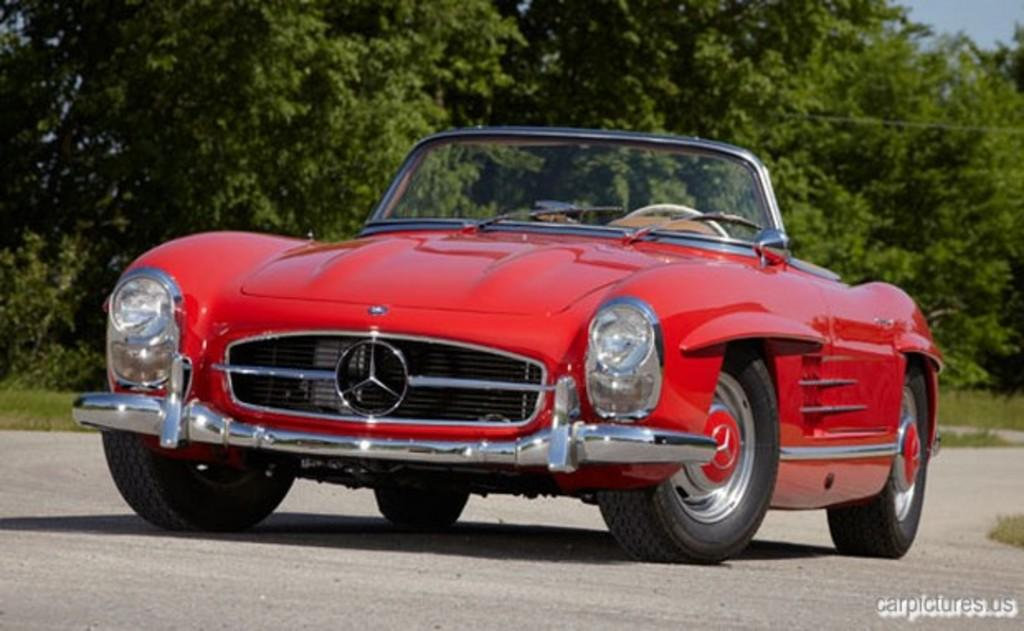What is the main subject of the image? The main subject of the image is a car on the road. What can be seen in the background of the image? There are trees and the sky visible in the background of the image. How deep is the hole in the image? There is no hole present in the image. What type of baseball equipment can be seen in the image? There is no baseball equipment present in the image. 